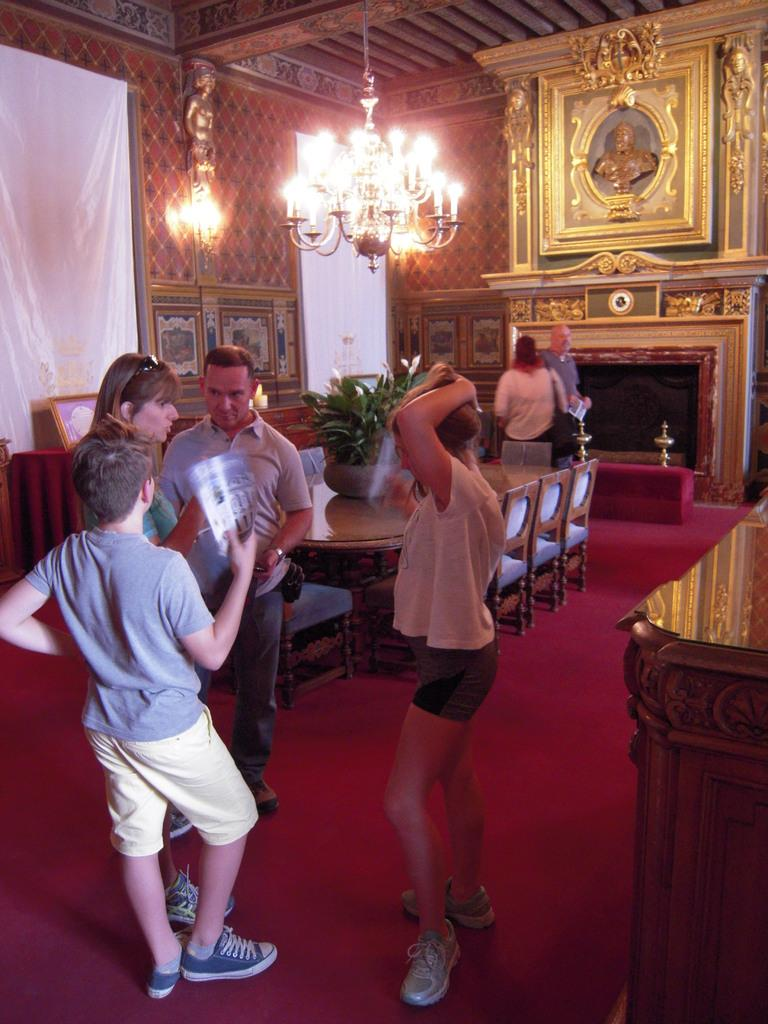How many people are in the image? There is a group of people in the image. Where are the people located? The people are standing in a room. What can be seen in the background of the image? There are lights, photo albums, a table, and a flower pot in the background of the image. What type of discovery was made during the experience in the image? There is no indication of a discovery or experience in the image; it simply shows a group of people standing in a room with various objects in the background. 